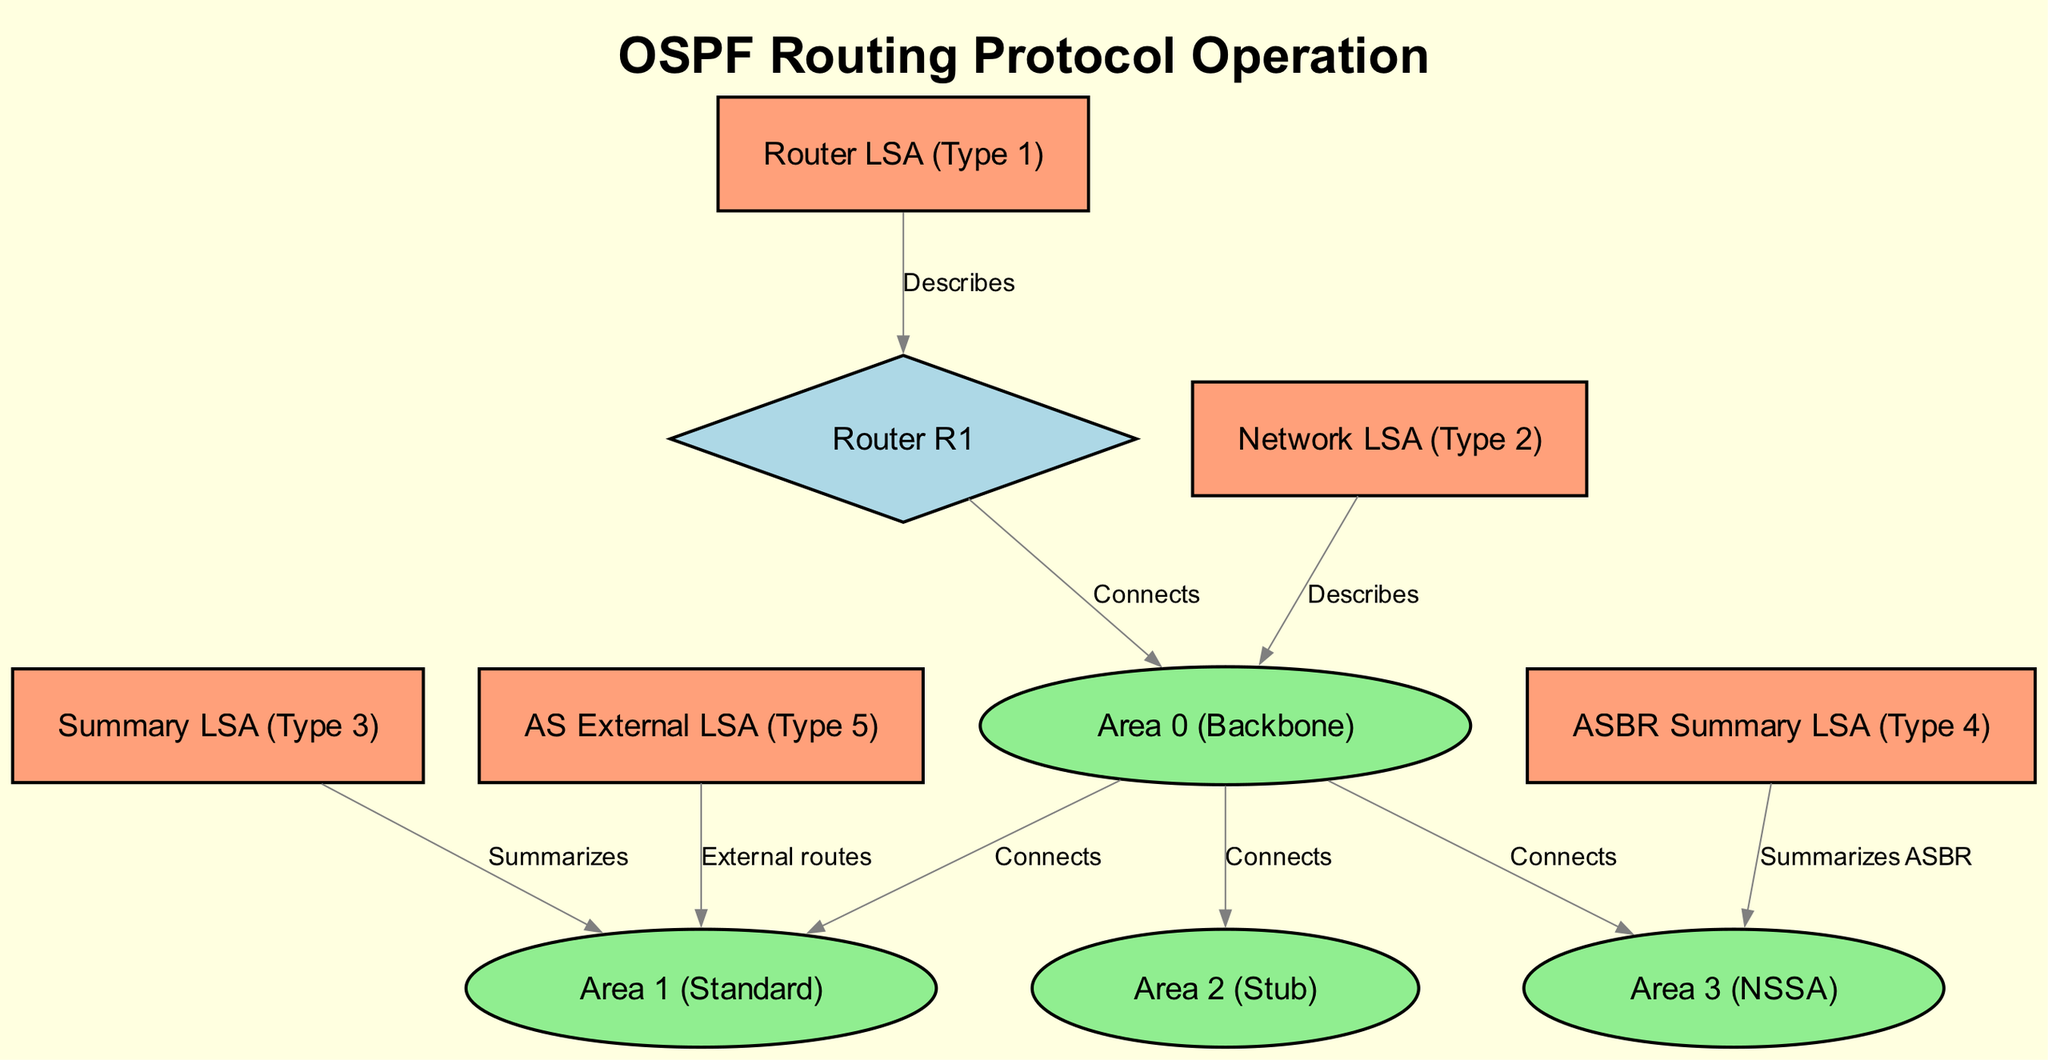What nodes are included in the diagram? The diagram includes several nodes, specifically Router R1, Area 0 (Backbone), Area 1 (Standard), Area 2 (Stub), Area 3 (NSSA), Router LSA (Type 1), Network LSA (Type 2), Summary LSA (Type 3), ASBR Summary LSA (Type 4), and AS External LSA (Type 5). Counting each one, we find a total of ten nodes in the diagram.
Answer: ten What type of area is Area 2? Referring to the diagram, Area 2 is specifically labeled as a "Stub," which distinguishes it from other areas shown (like Backbone or NSSA). This information is directly provided in the labeling of the nodes.
Answer: Stub How many different types of LSA are represented? The diagram illustrates five different types of LSA: Router LSA (Type 1), Network LSA (Type 2), Summary LSA (Type 3), ASBR Summary LSA (Type 4), and AS External LSA (Type 5). This can be confirmed by counting the LSA nodes visually presented in the diagram.
Answer: five Which area type connects to the Router R1? The edge connection details show that Router R1 is connected to Area 0, which is marked as the Backbone area. This can be verified by looking at the arrow and label indicating the connection in the diagram.
Answer: Area 0 (Backbone) What does the Network LSA (Type 2) describe? The diagram indicates that the Network LSA (Type 2) describes Area 2 (Stub) through an edge labeled "Describes." This shows the relationship and description function in the context of OSPF routing topology.
Answer: Area 2 (Stub) Which LSA summarizes ASBR summary information? By examining the edges connected to various LSA nodes, it's evident that the ASBR Summary LSA (Type 4) summarizes information related to Area 5 (NSSA). This relationship is specified by the edge labeled "Summarizes ASBR."
Answer: Area 5 (NSSA) What areas are connected to Area 0? Upon reviewing the edges from Area 0 presented in the diagram, it can be seen that it connects to Area 1, Area 2, and Area 3. Counting these connections gives us three areas directly connected to Area 0.
Answer: three 